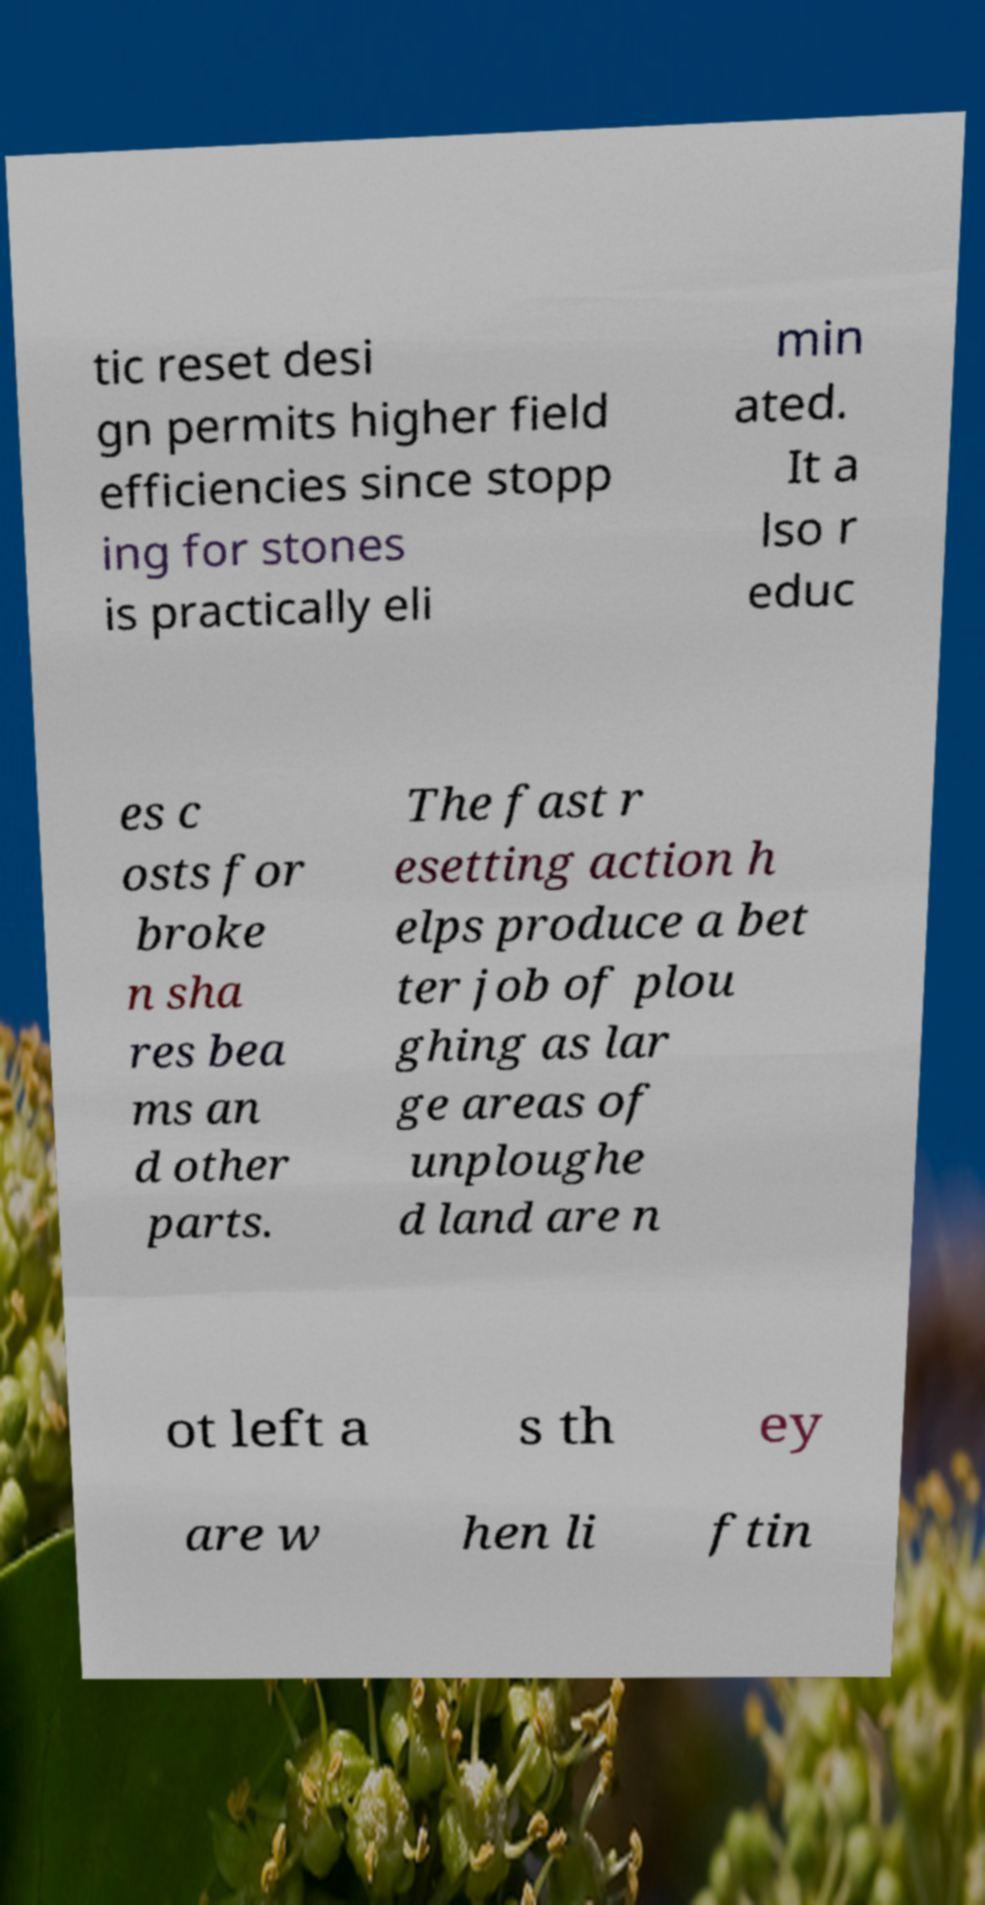Can you read and provide the text displayed in the image?This photo seems to have some interesting text. Can you extract and type it out for me? tic reset desi gn permits higher field efficiencies since stopp ing for stones is practically eli min ated. It a lso r educ es c osts for broke n sha res bea ms an d other parts. The fast r esetting action h elps produce a bet ter job of plou ghing as lar ge areas of unploughe d land are n ot left a s th ey are w hen li ftin 